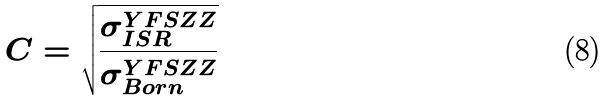<formula> <loc_0><loc_0><loc_500><loc_500>C = \sqrt { \frac { \sigma ^ { Y F S Z Z } _ { I S R } } { \sigma ^ { Y F S Z Z } _ { B o r n } } }</formula> 